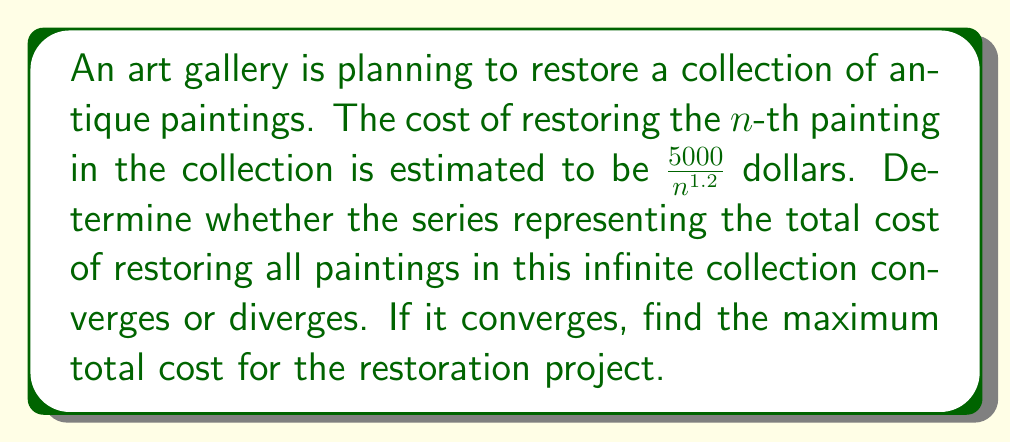Provide a solution to this math problem. Let's approach this step-by-step:

1) The series representing the total cost is:

   $$\sum_{n=1}^{\infty} \frac{5000}{n^{1.2}}$$

2) To analyze convergence, we can use the p-series test. A p-series is of the form $\sum_{n=1}^{\infty} \frac{1}{n^p}$, and it converges if and only if $p > 1$.

3) In our case, we can rewrite the series as:

   $$5000 \sum_{n=1}^{\infty} \frac{1}{n^{1.2}}$$

4) Here, $p = 1.2$, which is greater than 1.

5) Therefore, this series converges.

6) To find the sum of this convergent series, we can use the following approximation for p-series:

   $$\sum_{n=1}^{\infty} \frac{1}{n^p} \approx \frac{1}{p-1} + \frac{1}{2} + \frac{1}{p2^p}$$

7) Substituting $p = 1.2$:

   $$\sum_{n=1}^{\infty} \frac{1}{n^{1.2}} \approx \frac{1}{0.2} + \frac{1}{2} + \frac{1}{1.2 \cdot 2^{1.2}} \approx 5.8435$$

8) Multiplying by 5000:

   $$5000 \cdot 5.8435 = 29,217.5$$

Thus, the maximum total cost for the restoration project is approximately $29,217.50.
Answer: Converges; $29,217.50 